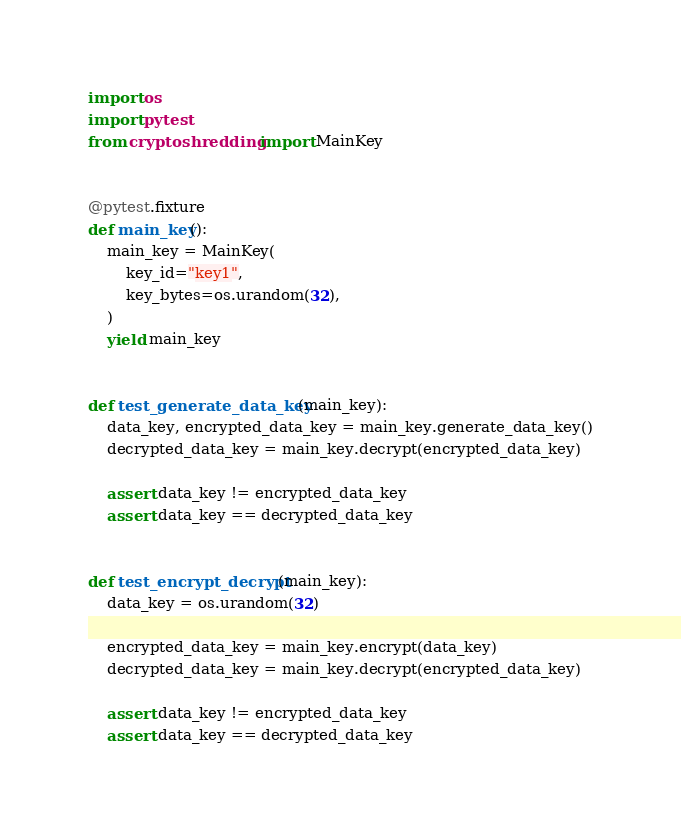Convert code to text. <code><loc_0><loc_0><loc_500><loc_500><_Python_>import os
import pytest
from cryptoshredding import MainKey


@pytest.fixture
def main_key():
    main_key = MainKey(
        key_id="key1",
        key_bytes=os.urandom(32),
    )
    yield main_key


def test_generate_data_key(main_key):
    data_key, encrypted_data_key = main_key.generate_data_key()
    decrypted_data_key = main_key.decrypt(encrypted_data_key)

    assert data_key != encrypted_data_key
    assert data_key == decrypted_data_key


def test_encrypt_decrypt(main_key):
    data_key = os.urandom(32)

    encrypted_data_key = main_key.encrypt(data_key)
    decrypted_data_key = main_key.decrypt(encrypted_data_key)

    assert data_key != encrypted_data_key
    assert data_key == decrypted_data_key
</code> 